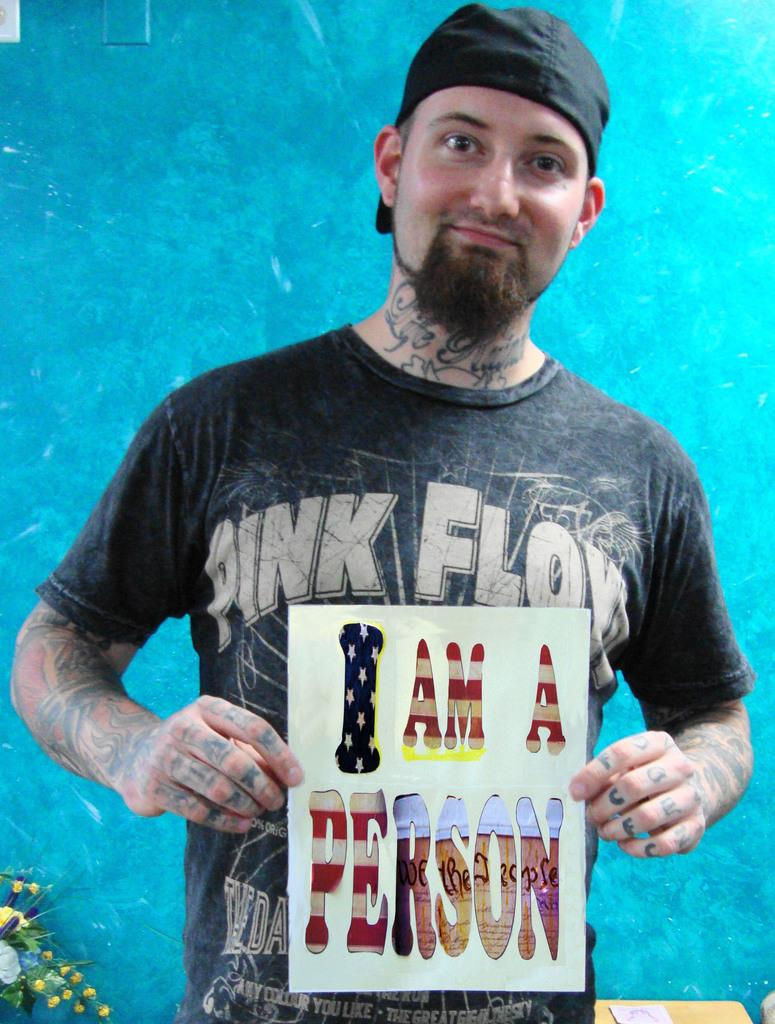What can be seen in the image? There is a person in the image. Can you describe the person's appearance? The person is wearing clothes. What is the person holding in the image? The person is holding a placard. What else can be seen in the image? There is an object in the bottom left of the image. Can you see any cherries on the playground in the image? There is no playground or cherries present in the image. 